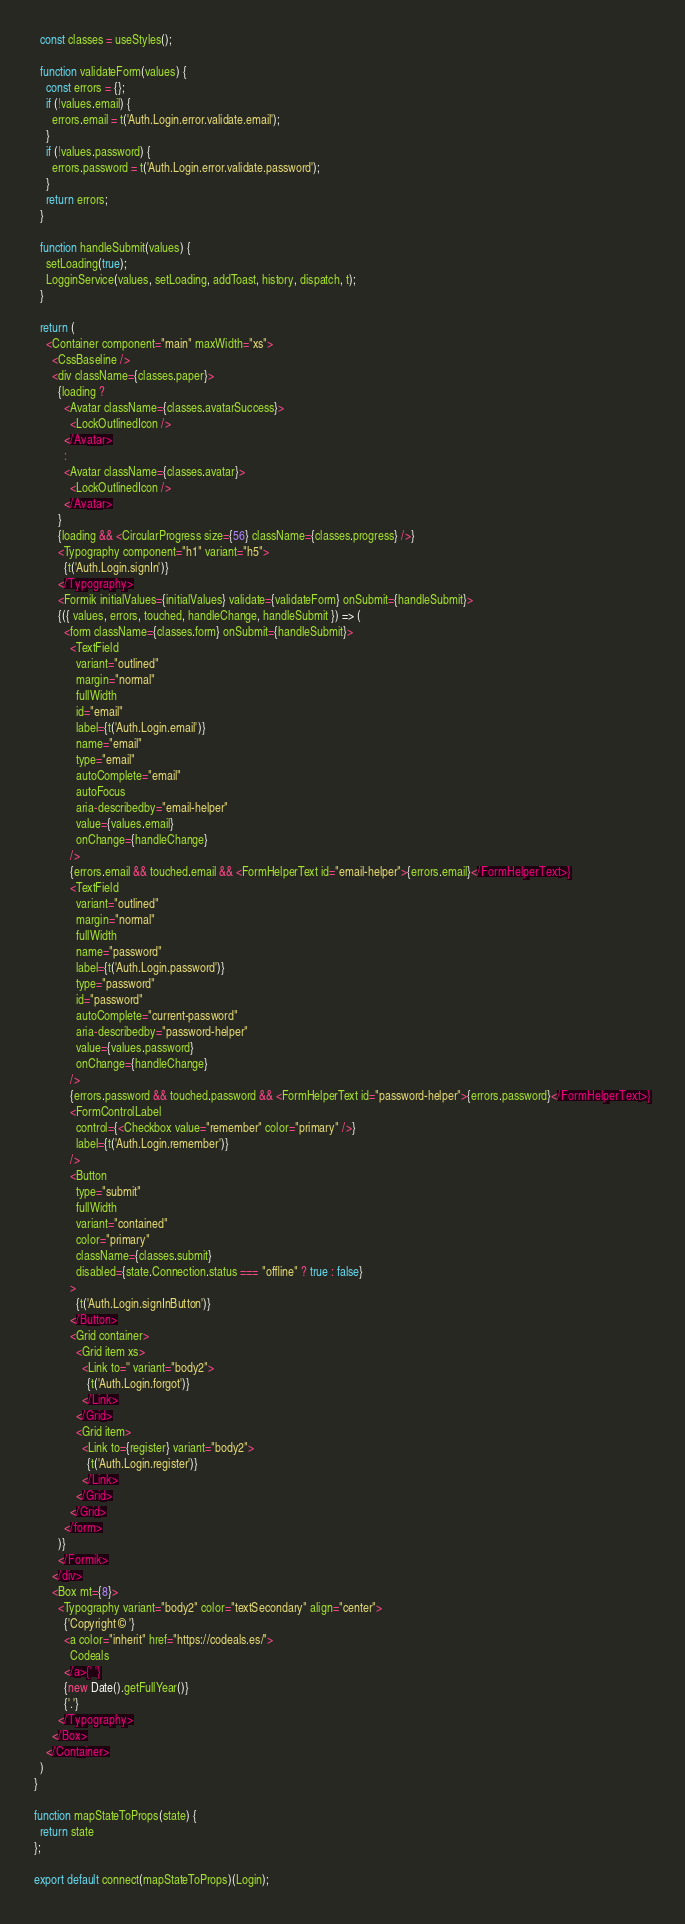Convert code to text. <code><loc_0><loc_0><loc_500><loc_500><_JavaScript_>  const classes = useStyles();

  function validateForm(values) {
    const errors = {};
    if (!values.email) {
      errors.email = t('Auth.Login.error.validate.email');
    }
    if (!values.password) {
      errors.password = t('Auth.Login.error.validate.password');
    }
    return errors;
  }

  function handleSubmit(values) {
    setLoading(true);
    LogginService(values, setLoading, addToast, history, dispatch, t);
  }

  return (
    <Container component="main" maxWidth="xs">
      <CssBaseline />
      <div className={classes.paper}>
        {loading ? 
          <Avatar className={classes.avatarSuccess}>
            <LockOutlinedIcon />
          </Avatar>
          :
          <Avatar className={classes.avatar}>
            <LockOutlinedIcon />
          </Avatar>
        }
        {loading && <CircularProgress size={56} className={classes.progress} />}
        <Typography component="h1" variant="h5">
          {t('Auth.Login.signIn')}
        </Typography>
        <Formik initialValues={initialValues} validate={validateForm} onSubmit={handleSubmit}>
        {({ values, errors, touched, handleChange, handleSubmit }) => (
          <form className={classes.form} onSubmit={handleSubmit}>
            <TextField
              variant="outlined"
              margin="normal"
              fullWidth
              id="email"
              label={t('Auth.Login.email')}
              name="email"
              type="email"
              autoComplete="email"
              autoFocus
              aria-describedby="email-helper"
              value={values.email}
              onChange={handleChange}
            />
            {errors.email && touched.email && <FormHelperText id="email-helper">{errors.email}</FormHelperText>}
            <TextField
              variant="outlined"
              margin="normal"
              fullWidth
              name="password"
              label={t('Auth.Login.password')}
              type="password"
              id="password"
              autoComplete="current-password"
              aria-describedby="password-helper"
              value={values.password}
              onChange={handleChange}
            />
            {errors.password && touched.password && <FormHelperText id="password-helper">{errors.password}</FormHelperText>}
            <FormControlLabel
              control={<Checkbox value="remember" color="primary" />}
              label={t('Auth.Login.remember')}
            />
            <Button
              type="submit"
              fullWidth
              variant="contained"
              color="primary"
              className={classes.submit}
              disabled={state.Connection.status === "offline" ? true : false}
            >
              {t('Auth.Login.signInButton')}
            </Button>
            <Grid container>
              <Grid item xs>
                <Link to='' variant="body2">
                  {t('Auth.Login.forgot')}
                </Link>
              </Grid>
              <Grid item>
                <Link to={register} variant="body2">
                  {t('Auth.Login.register')}
                </Link>
              </Grid>
            </Grid>
          </form>
        )}
        </Formik>
      </div>
      <Box mt={8}>
        <Typography variant="body2" color="textSecondary" align="center">
          {'Copyright © '}
          <a color="inherit" href="https://codeals.es/">
            Codeals
          </a>{' '}
          {new Date().getFullYear()}
          {'.'}
        </Typography>
      </Box>
    </Container>
  )
}

function mapStateToProps(state) {
  return state
};

export default connect(mapStateToProps)(Login);</code> 